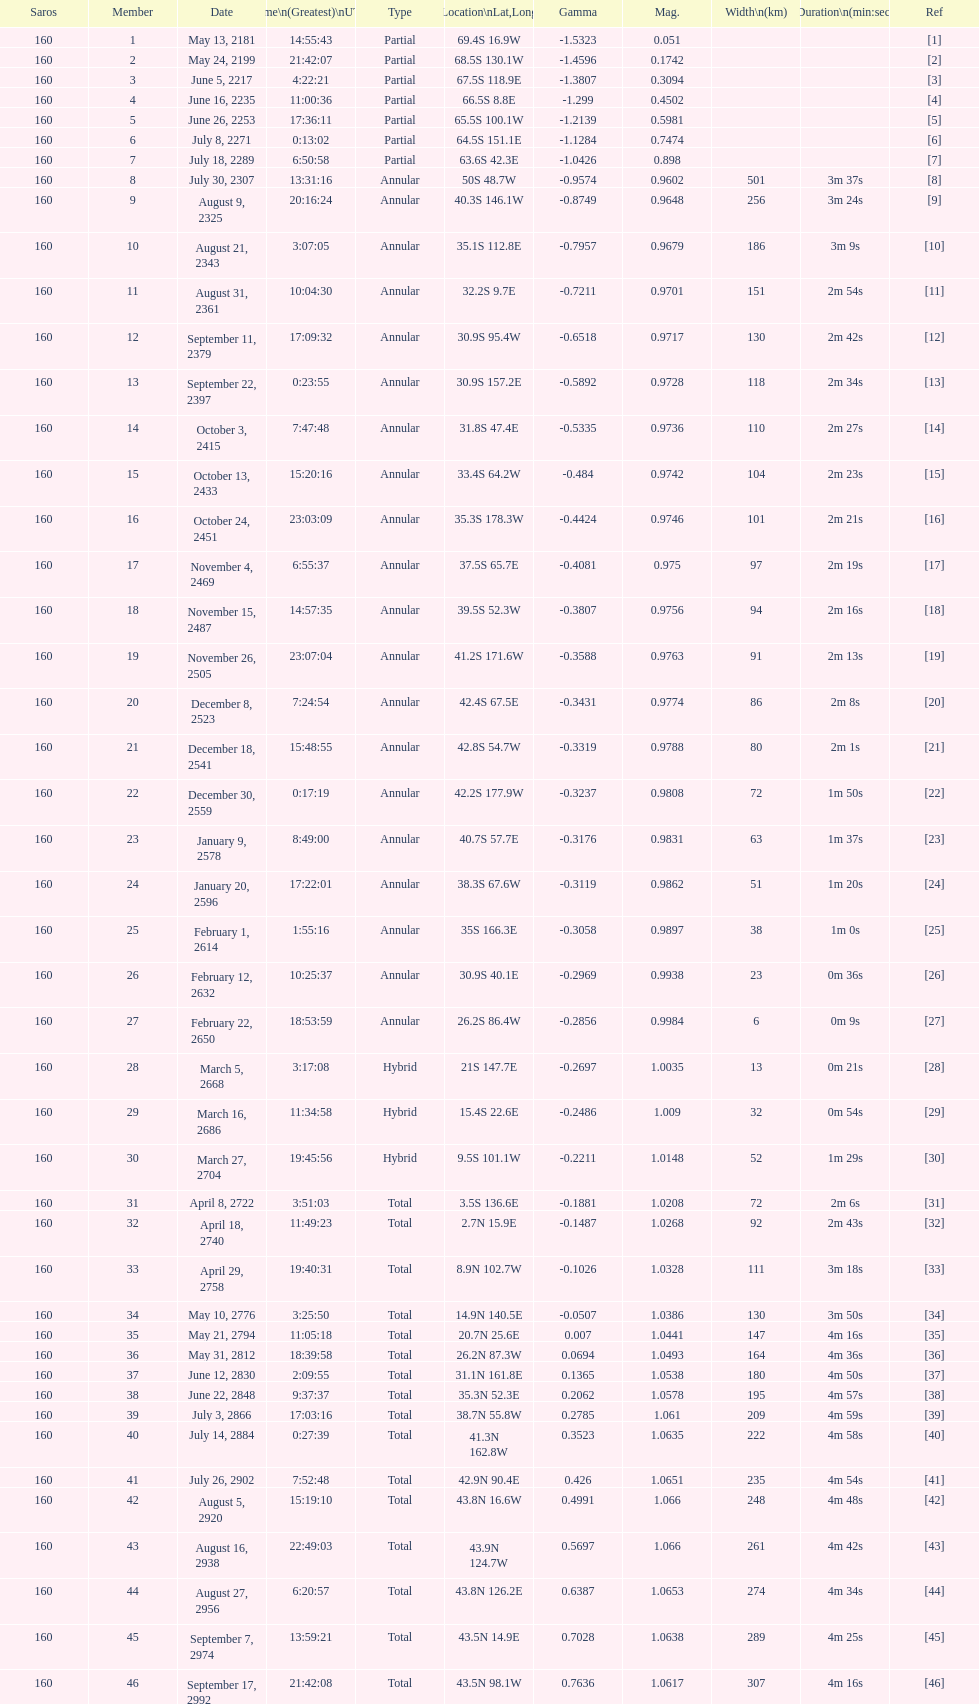Which one has a larger width, 8 or 21? 8. 